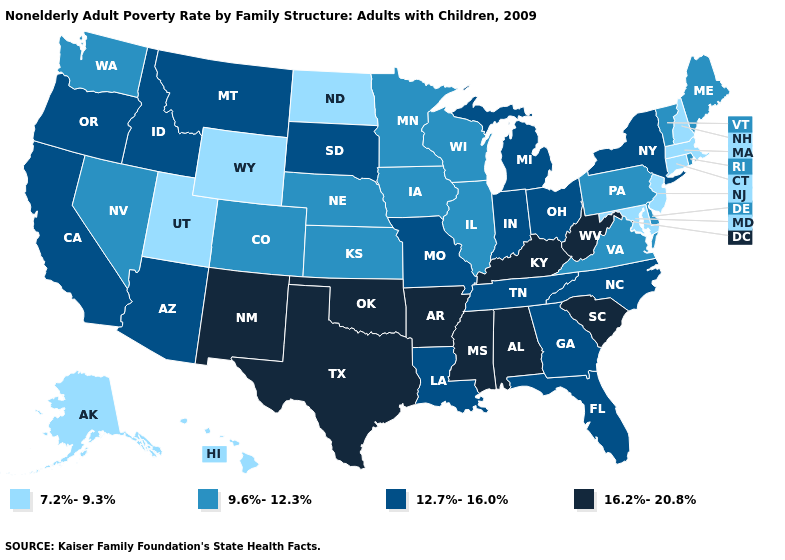Name the states that have a value in the range 16.2%-20.8%?
Short answer required. Alabama, Arkansas, Kentucky, Mississippi, New Mexico, Oklahoma, South Carolina, Texas, West Virginia. Name the states that have a value in the range 12.7%-16.0%?
Answer briefly. Arizona, California, Florida, Georgia, Idaho, Indiana, Louisiana, Michigan, Missouri, Montana, New York, North Carolina, Ohio, Oregon, South Dakota, Tennessee. Name the states that have a value in the range 9.6%-12.3%?
Answer briefly. Colorado, Delaware, Illinois, Iowa, Kansas, Maine, Minnesota, Nebraska, Nevada, Pennsylvania, Rhode Island, Vermont, Virginia, Washington, Wisconsin. Name the states that have a value in the range 9.6%-12.3%?
Concise answer only. Colorado, Delaware, Illinois, Iowa, Kansas, Maine, Minnesota, Nebraska, Nevada, Pennsylvania, Rhode Island, Vermont, Virginia, Washington, Wisconsin. What is the value of New Hampshire?
Give a very brief answer. 7.2%-9.3%. What is the value of Louisiana?
Be succinct. 12.7%-16.0%. What is the value of Washington?
Give a very brief answer. 9.6%-12.3%. What is the value of New Jersey?
Be succinct. 7.2%-9.3%. Name the states that have a value in the range 7.2%-9.3%?
Concise answer only. Alaska, Connecticut, Hawaii, Maryland, Massachusetts, New Hampshire, New Jersey, North Dakota, Utah, Wyoming. Name the states that have a value in the range 7.2%-9.3%?
Answer briefly. Alaska, Connecticut, Hawaii, Maryland, Massachusetts, New Hampshire, New Jersey, North Dakota, Utah, Wyoming. Among the states that border Pennsylvania , does Delaware have the highest value?
Keep it brief. No. Which states have the lowest value in the USA?
Answer briefly. Alaska, Connecticut, Hawaii, Maryland, Massachusetts, New Hampshire, New Jersey, North Dakota, Utah, Wyoming. Does the map have missing data?
Quick response, please. No. 